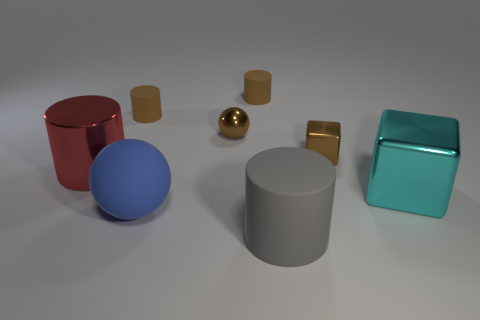Subtract 1 cylinders. How many cylinders are left? 3 Add 1 small gray cubes. How many objects exist? 9 Subtract all balls. How many objects are left? 6 Add 4 small brown blocks. How many small brown blocks exist? 5 Subtract 0 red balls. How many objects are left? 8 Subtract all large blue objects. Subtract all tiny brown matte cylinders. How many objects are left? 5 Add 5 gray cylinders. How many gray cylinders are left? 6 